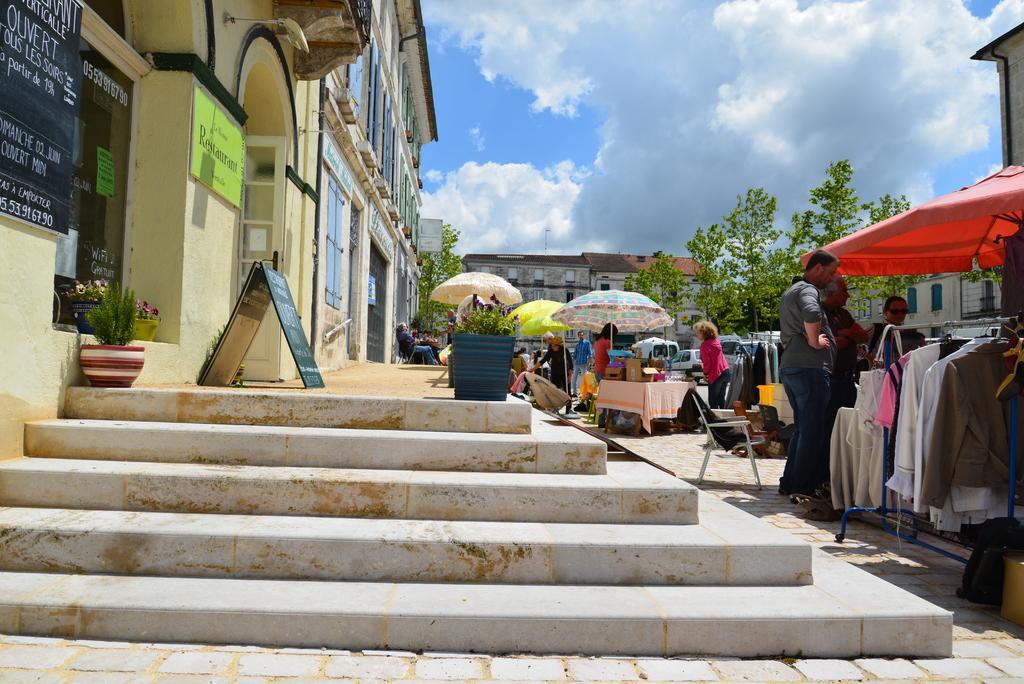Can you describe this image briefly? This is an outside view. On the right side there are few umbrellas, under these people are standing and also I can see few clothes are hanging to the metal stands. There are few tables and chairs. At the bottom, I can see the stairs. On the stairs there are few plant pots and a board are placed. In the background, I can see few buildings and trees. At the top of the image I can see the sky and clouds. 